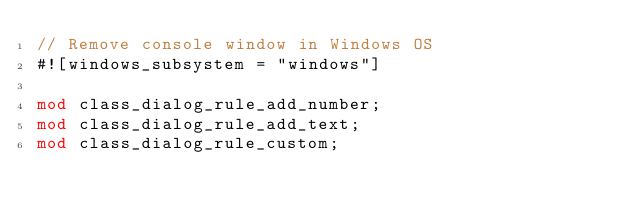Convert code to text. <code><loc_0><loc_0><loc_500><loc_500><_Rust_>// Remove console window in Windows OS
#![windows_subsystem = "windows"]

mod class_dialog_rule_add_number;
mod class_dialog_rule_add_text;
mod class_dialog_rule_custom;</code> 